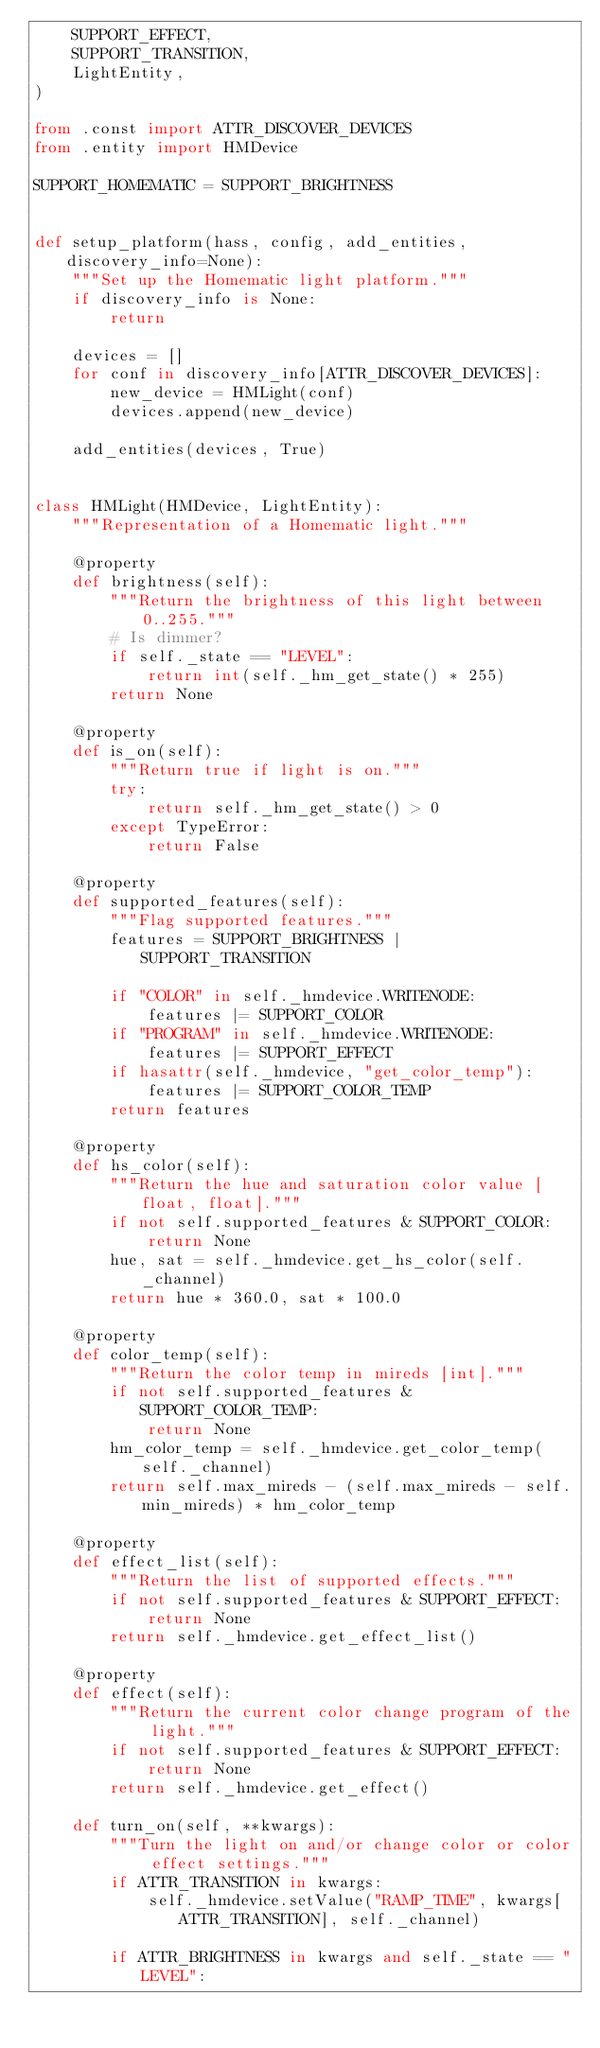Convert code to text. <code><loc_0><loc_0><loc_500><loc_500><_Python_>    SUPPORT_EFFECT,
    SUPPORT_TRANSITION,
    LightEntity,
)

from .const import ATTR_DISCOVER_DEVICES
from .entity import HMDevice

SUPPORT_HOMEMATIC = SUPPORT_BRIGHTNESS


def setup_platform(hass, config, add_entities, discovery_info=None):
    """Set up the Homematic light platform."""
    if discovery_info is None:
        return

    devices = []
    for conf in discovery_info[ATTR_DISCOVER_DEVICES]:
        new_device = HMLight(conf)
        devices.append(new_device)

    add_entities(devices, True)


class HMLight(HMDevice, LightEntity):
    """Representation of a Homematic light."""

    @property
    def brightness(self):
        """Return the brightness of this light between 0..255."""
        # Is dimmer?
        if self._state == "LEVEL":
            return int(self._hm_get_state() * 255)
        return None

    @property
    def is_on(self):
        """Return true if light is on."""
        try:
            return self._hm_get_state() > 0
        except TypeError:
            return False

    @property
    def supported_features(self):
        """Flag supported features."""
        features = SUPPORT_BRIGHTNESS | SUPPORT_TRANSITION

        if "COLOR" in self._hmdevice.WRITENODE:
            features |= SUPPORT_COLOR
        if "PROGRAM" in self._hmdevice.WRITENODE:
            features |= SUPPORT_EFFECT
        if hasattr(self._hmdevice, "get_color_temp"):
            features |= SUPPORT_COLOR_TEMP
        return features

    @property
    def hs_color(self):
        """Return the hue and saturation color value [float, float]."""
        if not self.supported_features & SUPPORT_COLOR:
            return None
        hue, sat = self._hmdevice.get_hs_color(self._channel)
        return hue * 360.0, sat * 100.0

    @property
    def color_temp(self):
        """Return the color temp in mireds [int]."""
        if not self.supported_features & SUPPORT_COLOR_TEMP:
            return None
        hm_color_temp = self._hmdevice.get_color_temp(self._channel)
        return self.max_mireds - (self.max_mireds - self.min_mireds) * hm_color_temp

    @property
    def effect_list(self):
        """Return the list of supported effects."""
        if not self.supported_features & SUPPORT_EFFECT:
            return None
        return self._hmdevice.get_effect_list()

    @property
    def effect(self):
        """Return the current color change program of the light."""
        if not self.supported_features & SUPPORT_EFFECT:
            return None
        return self._hmdevice.get_effect()

    def turn_on(self, **kwargs):
        """Turn the light on and/or change color or color effect settings."""
        if ATTR_TRANSITION in kwargs:
            self._hmdevice.setValue("RAMP_TIME", kwargs[ATTR_TRANSITION], self._channel)

        if ATTR_BRIGHTNESS in kwargs and self._state == "LEVEL":</code> 